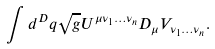<formula> <loc_0><loc_0><loc_500><loc_500>\int d ^ { D } q \sqrt { g } U ^ { \mu \nu _ { 1 } \dots \nu _ { n } } D _ { \mu } V _ { \nu _ { 1 } \dots \nu _ { n } } .</formula> 